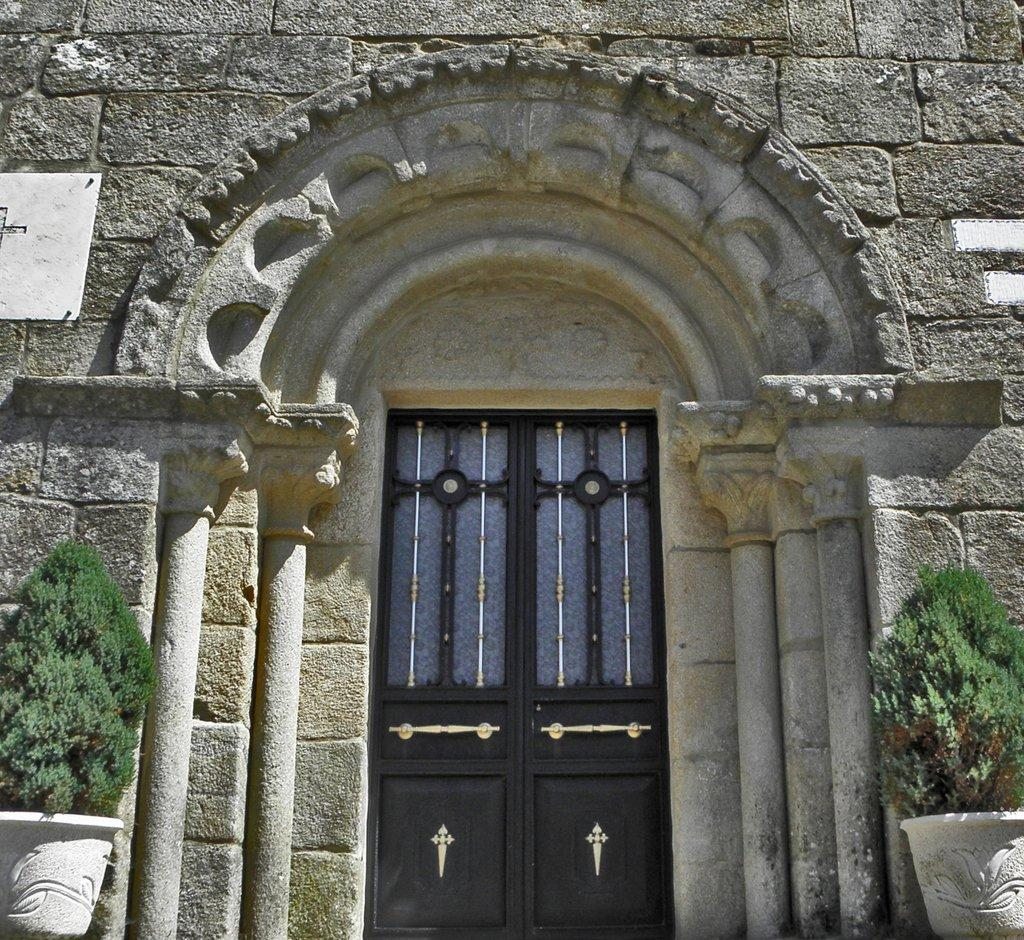What type of door is visible in the image? There is a wooden door in the image in the image. What material is used for the wall in the image? There is a stone wall in the image. Where are the flower pots located in the image? The flower pots are on either side of the image. What type of yam is being grown in the flower pots in the image? There are no yams present in the image; the flower pots contain flowers. 